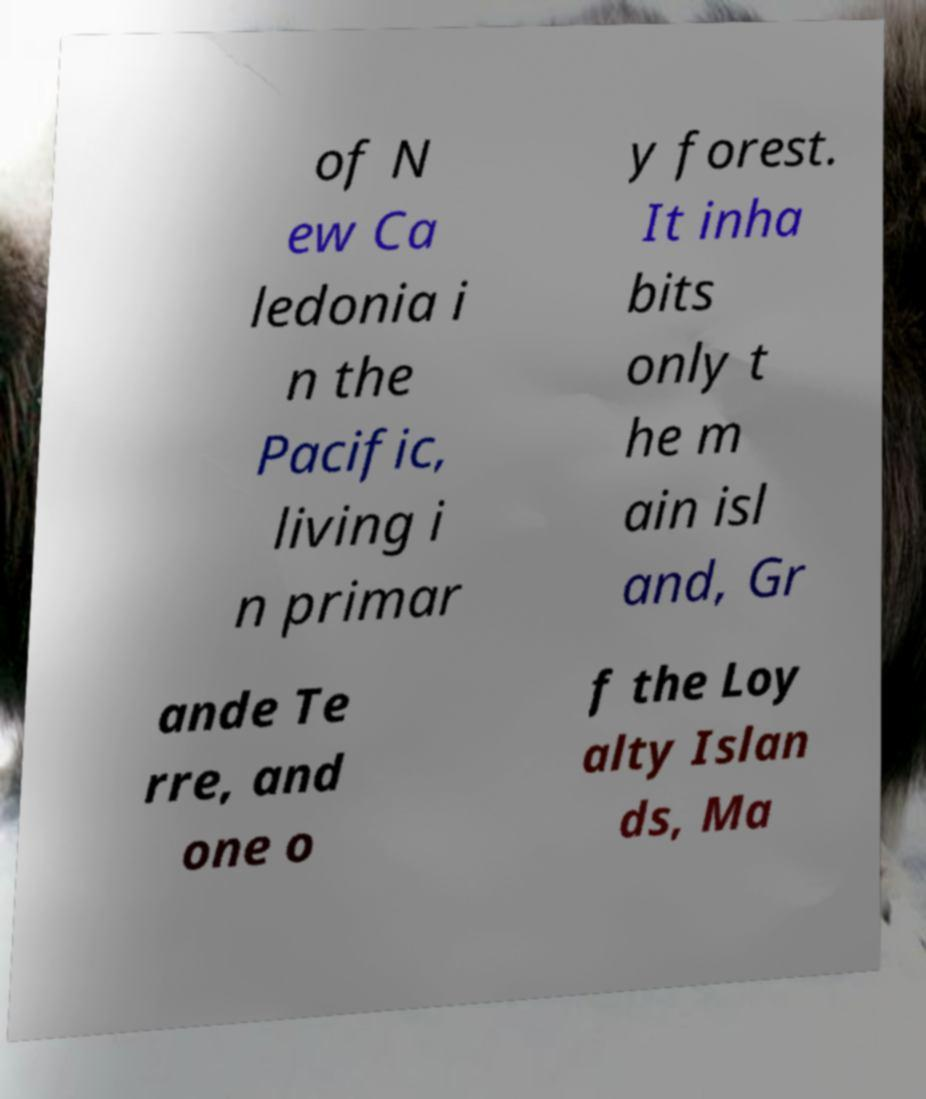Can you read and provide the text displayed in the image?This photo seems to have some interesting text. Can you extract and type it out for me? of N ew Ca ledonia i n the Pacific, living i n primar y forest. It inha bits only t he m ain isl and, Gr ande Te rre, and one o f the Loy alty Islan ds, Ma 